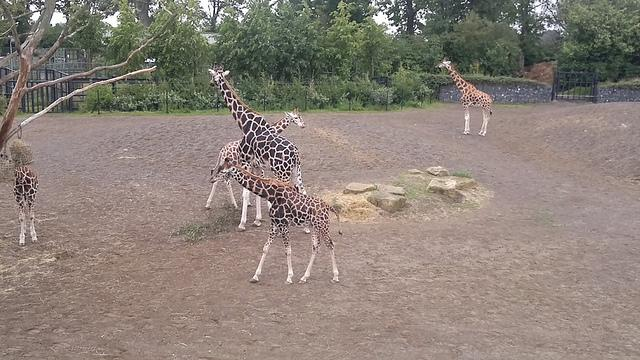What do these animals have? Please explain your reasoning. long necks. The tall animal is known for having an elongated nape. 